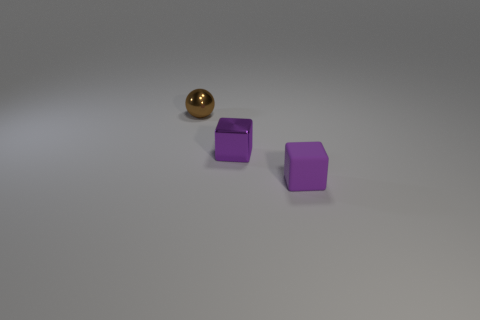The small brown shiny object has what shape?
Offer a terse response. Sphere. There is a purple thing that is the same size as the shiny cube; what material is it?
Offer a terse response. Rubber. How many large things are either red metal things or purple metallic things?
Offer a terse response. 0. Are any tiny yellow shiny spheres visible?
Offer a terse response. No. How many other things are there of the same material as the small brown sphere?
Offer a terse response. 1. What number of tiny things are in front of the tiny brown metallic sphere and behind the matte cube?
Provide a short and direct response. 1. What color is the shiny ball?
Ensure brevity in your answer.  Brown. What material is the other tiny thing that is the same shape as the purple matte thing?
Keep it short and to the point. Metal. Does the matte thing have the same color as the shiny cube?
Offer a very short reply. Yes. There is a object that is on the left side of the small metal object right of the brown shiny thing; what is its shape?
Provide a short and direct response. Sphere. 